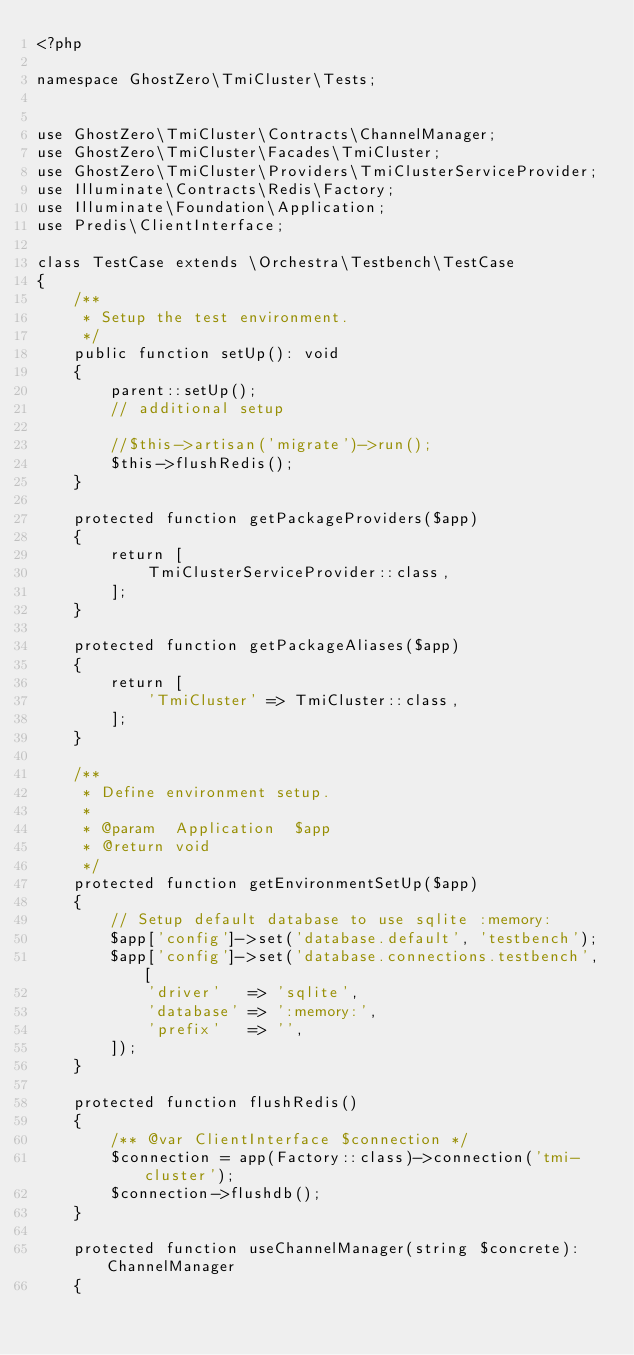Convert code to text. <code><loc_0><loc_0><loc_500><loc_500><_PHP_><?php

namespace GhostZero\TmiCluster\Tests;


use GhostZero\TmiCluster\Contracts\ChannelManager;
use GhostZero\TmiCluster\Facades\TmiCluster;
use GhostZero\TmiCluster\Providers\TmiClusterServiceProvider;
use Illuminate\Contracts\Redis\Factory;
use Illuminate\Foundation\Application;
use Predis\ClientInterface;

class TestCase extends \Orchestra\Testbench\TestCase
{
    /**
     * Setup the test environment.
     */
    public function setUp(): void
    {
        parent::setUp();
        // additional setup

        //$this->artisan('migrate')->run();
        $this->flushRedis();
    }

    protected function getPackageProviders($app)
    {
        return [
            TmiClusterServiceProvider::class,
        ];
    }

    protected function getPackageAliases($app)
    {
        return [
            'TmiCluster' => TmiCluster::class,
        ];
    }

    /**
     * Define environment setup.
     *
     * @param  Application  $app
     * @return void
     */
    protected function getEnvironmentSetUp($app)
    {
        // Setup default database to use sqlite :memory:
        $app['config']->set('database.default', 'testbench');
        $app['config']->set('database.connections.testbench', [
            'driver'   => 'sqlite',
            'database' => ':memory:',
            'prefix'   => '',
        ]);
    }

    protected function flushRedis()
    {
        /** @var ClientInterface $connection */
        $connection = app(Factory::class)->connection('tmi-cluster');
        $connection->flushdb();
    }

    protected function useChannelManager(string $concrete): ChannelManager
    {</code> 